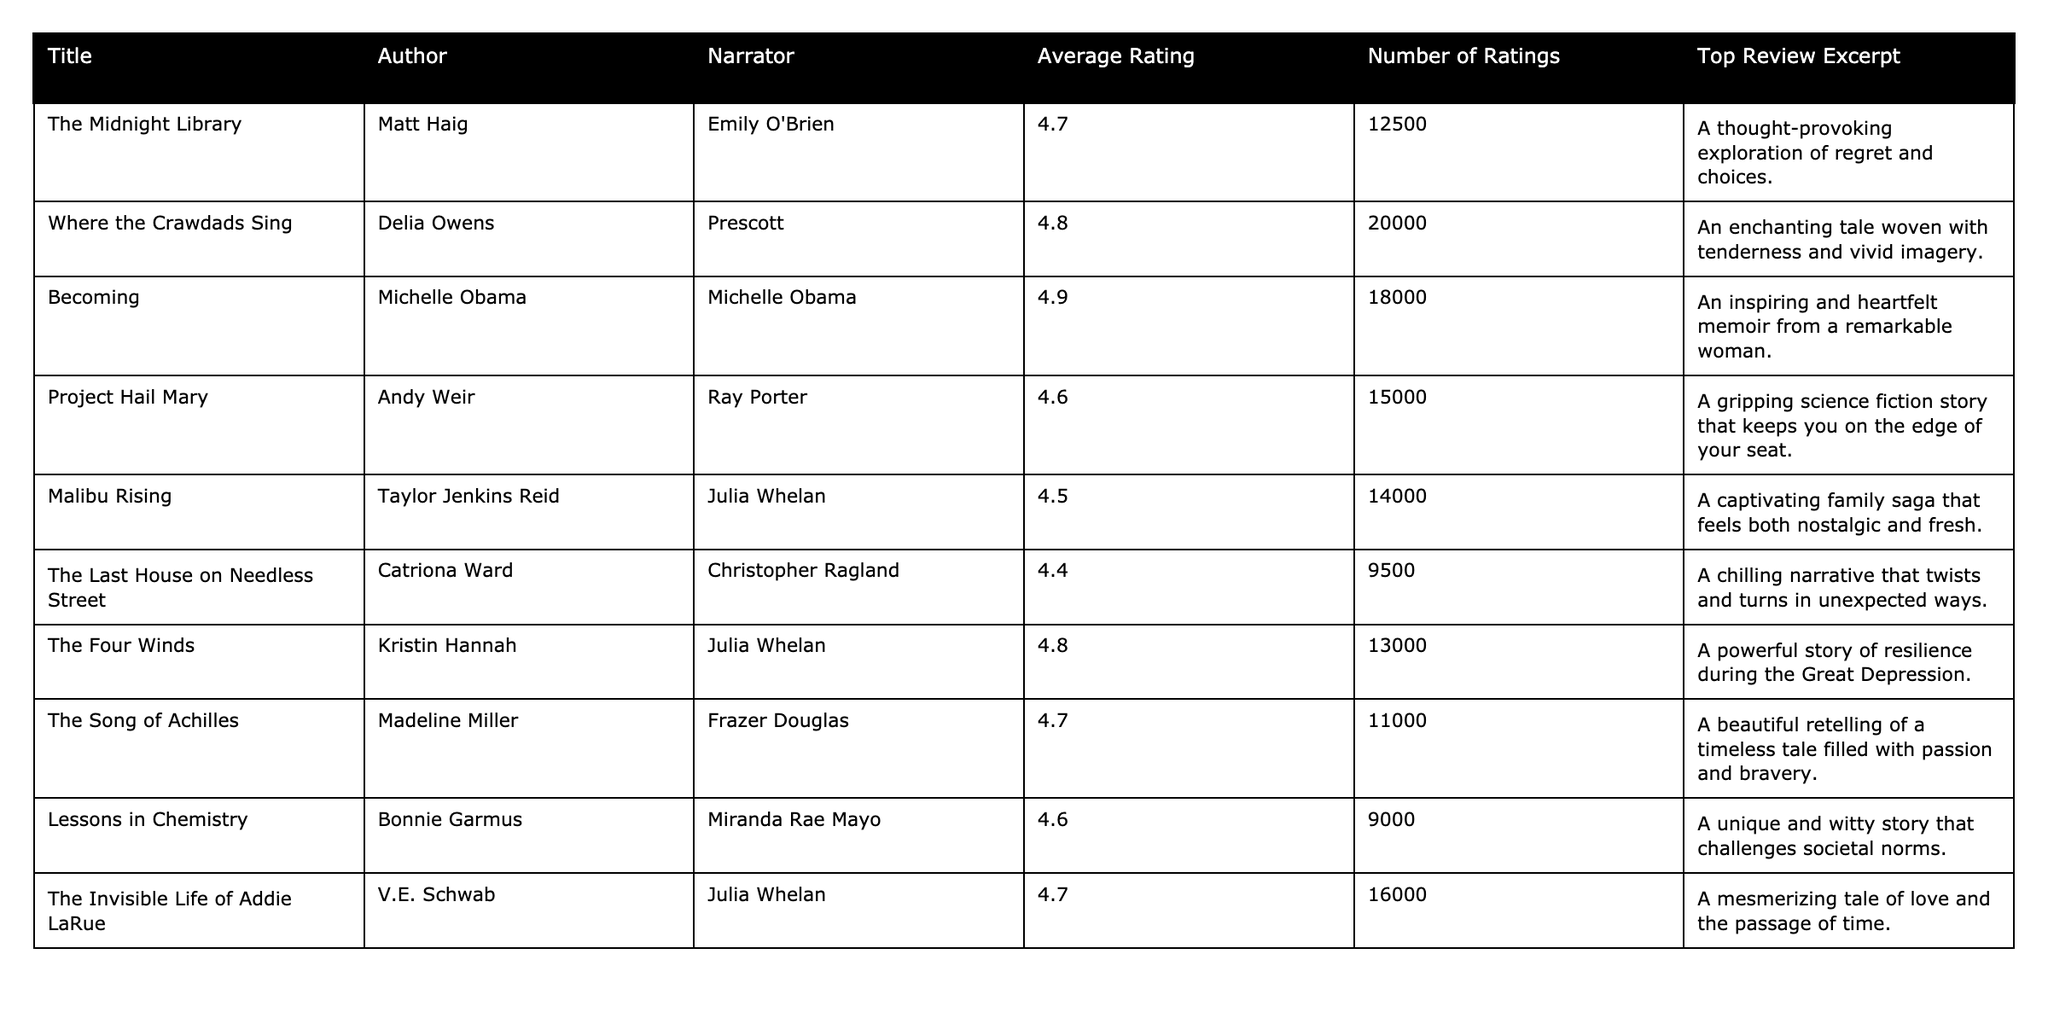What is the average rating of "Becoming"? The average rating for "Becoming" is listed in the table under the Average Rating column, which shows a value of 4.9.
Answer: 4.9 How many ratings does "Where the Crawdads Sing" have? The number of ratings for "Where the Crawdads Sing" is found in the Number of Ratings column, which indicates that it has 20,000 ratings.
Answer: 20,000 Which audiobook has the highest average rating? By examining the Average Rating column, we can see that "Becoming" has the highest average rating at 4.9.
Answer: "Becoming" Is "The Last House on Needless Street" rated above 4.5? The average rating for "The Last House on Needless Street" is found in the Average Rating column and is 4.4, which is below 4.5.
Answer: No What is the difference in average ratings between "The Invisible Life of Addie LaRue" and "Malibu Rising"? The average rating for "The Invisible Life of Addie LaRue" is 4.7, while "Malibu Rising" has an average rating of 4.5. The difference is calculated as 4.7 - 4.5 = 0.2.
Answer: 0.2 Which narrator performed "The Four Winds"? The Narrator column indicates that "The Four Winds" was narrated by Julia Whelan.
Answer: Julia Whelan Which two audiobooks have the same average rating of 4.6? Looking at the Average Rating column, both "Project Hail Mary" and "Lessons in Chemistry" have an average rating of 4.6.
Answer: "Project Hail Mary" and "Lessons in Chemistry" How many total reviews do the top 10 audiobooks have? To find the total number of reviews, we sum the Number of Ratings for all audiobooks: 12500 + 20000 + 18000 + 15000 + 14000 + 9500 + 13000 + 11000 + 9000 + 16000 = 162,000.
Answer: 162,000 What percentage of the total ratings comes from "Becoming"? The total ratings across all audiobooks is 162,000, and "Becoming" has 18,000 ratings. The percentage is (18000/162000) * 100 = 11.11%.
Answer: 11.11% If we average the ratings of the top three audiobooks, what is the result? The top three audiobooks, ranked by average rating, are "Becoming" (4.9), "Where the Crawdads Sing" (4.8), and "The Four Winds" (4.8). The average is calculated as (4.9 + 4.8 + 4.8) / 3 = 4.83.
Answer: 4.83 